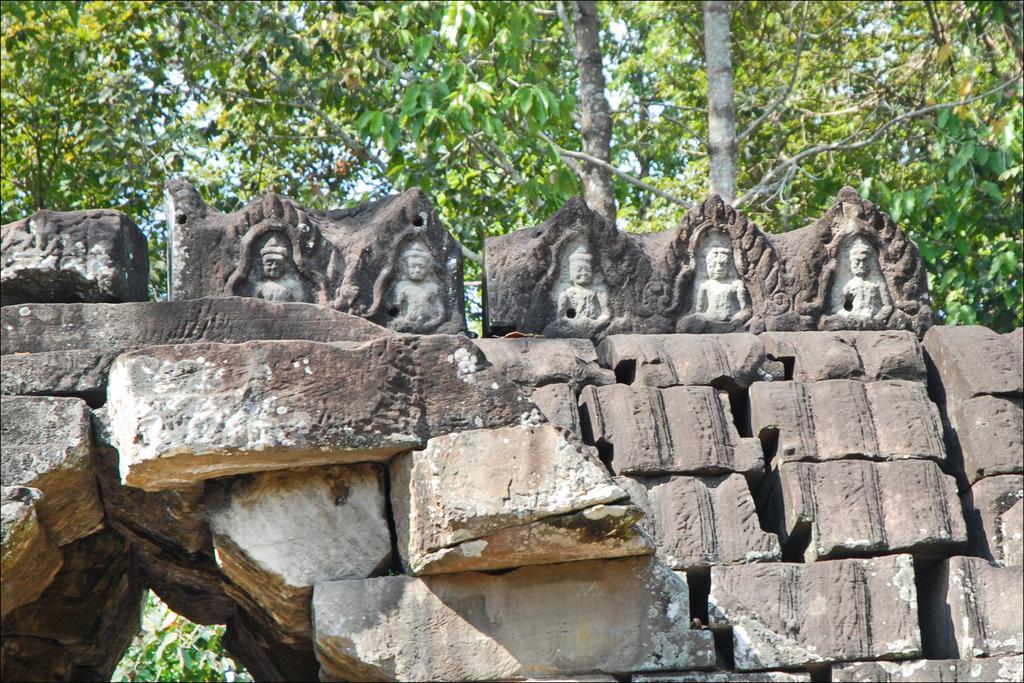Can you describe this image briefly? In front of the image there are rocks. On top of the rocks there are statues. Behind the statues there are trees. 